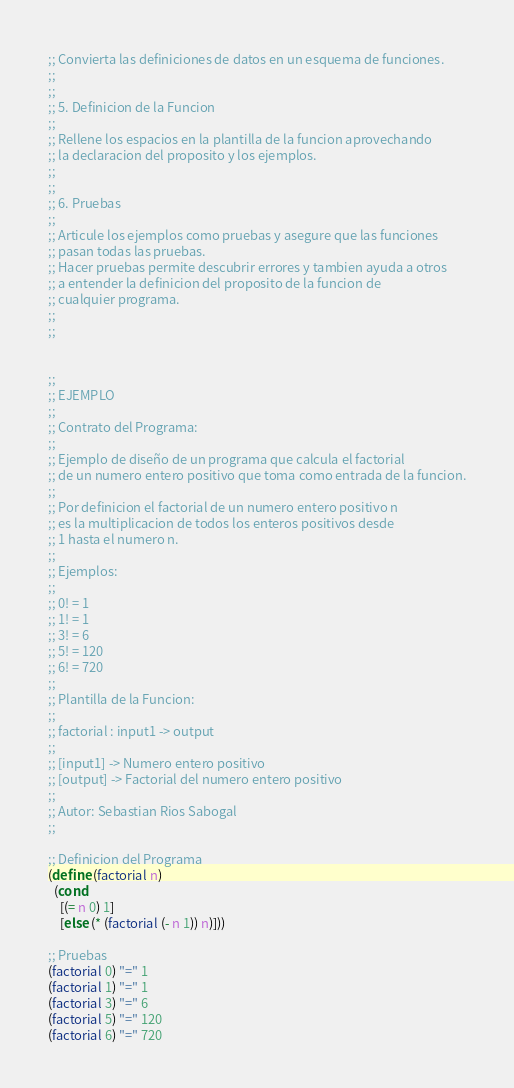Convert code to text. <code><loc_0><loc_0><loc_500><loc_500><_Scheme_>;; Convierta las definiciones de datos en un esquema de funciones.
;;
;;
;; 5. Definicion de la Funcion
;;
;; Rellene los espacios en la plantilla de la funcion aprovechando
;; la declaracion del proposito y los ejemplos.
;;
;;
;; 6. Pruebas
;;
;; Articule los ejemplos como pruebas y asegure que las funciones
;; pasan todas las pruebas.
;; Hacer pruebas permite descubrir errores y tambien ayuda a otros
;; a entender la definicion del proposito de la funcion de
;; cualquier programa.
;;
;;


;;
;; EJEMPLO
;;
;; Contrato del Programa:
;;
;; Ejemplo de diseño de un programa que calcula el factorial
;; de un numero entero positivo que toma como entrada de la funcion.
;;
;; Por definicion el factorial de un numero entero positivo n
;; es la multiplicacion de todos los enteros positivos desde
;; 1 hasta el numero n.
;;
;; Ejemplos:
;;
;; 0! = 1
;; 1! = 1
;; 3! = 6
;; 5! = 120
;; 6! = 720
;;
;; Plantilla de la Funcion:
;;
;; factorial : input1 -> output
;;
;; [input1] -> Numero entero positivo
;; [output] -> Factorial del numero entero positivo
;;
;; Autor: Sebastian Rios Sabogal
;;

;; Definicion del Programa
(define (factorial n)
  (cond
    [(= n 0) 1]
    [else (* (factorial (- n 1)) n)]))

;; Pruebas
(factorial 0) "=" 1
(factorial 1) "=" 1
(factorial 3) "=" 6
(factorial 5) "=" 120
(factorial 6) "=" 720
</code> 